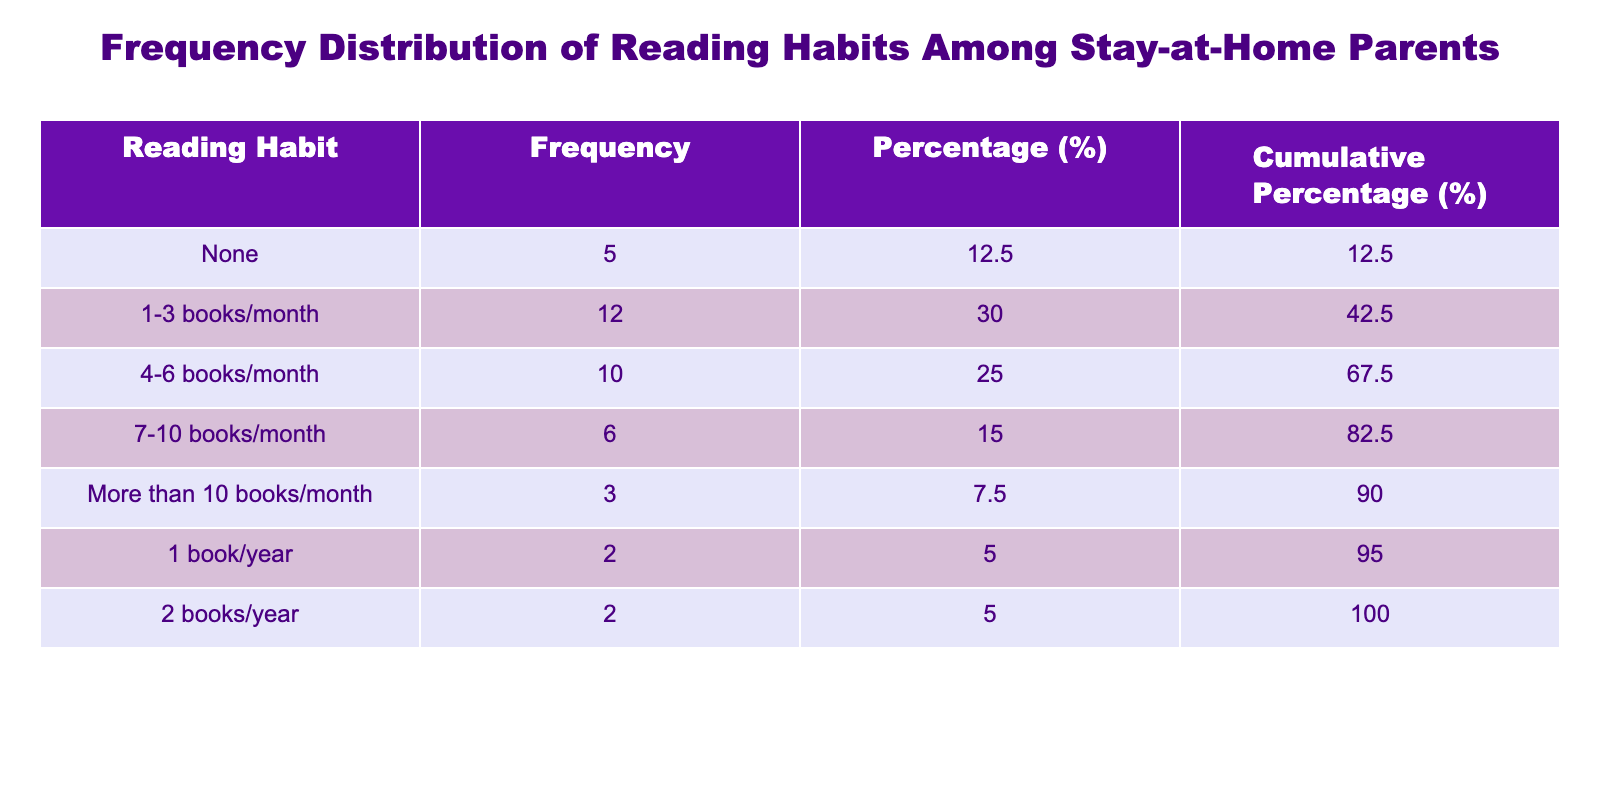What is the frequency of stay-at-home parents who read none? The table shows that the frequency of stay-at-home parents who read none is 5.
Answer: 5 How many parents read between 1 to 3 books per month? The table indicates that 12 parents read between 1 to 3 books per month.
Answer: 12 What is the percentage of stay-at-home parents who read more than 10 books per month? The frequency of parents reading more than 10 books per month is 3. To find the percentage, divide 3 by the total frequency (displays a sum of 50) and multiply by 100: (3/50)*100 = 6.00%.
Answer: 6.00% Is it true that more than half of the surveyed parents read 4 or more books per month? The total frequency of parents who read 4 or more books per month (10 + 6 + 3 = 19) is compared to the total frequency (50). Since 19 is less than 25, it shows that less than half read 4 or more books per month.
Answer: No What is the total frequency of parents reading 1 book per year or 2 books per year? The frequency for 1 book/year is 2 and for 2 books/year is also 2. Adding these gives: 2 + 2 = 4.
Answer: 4 How many more parents prefer to read 1-3 books per month than those who read 7-10 books per month? The frequency for 1-3 books/month is 12 and for 7-10 books/month is 6. The difference is calculated by subtracting: 12 - 6 = 6.
Answer: 6 What is the cumulative percentage of parents who read 1-3 books per month? The cumulative percentage for parents reading 1-3 books per month is calculated based on the percentages of prior categories. The percentage of 1-3 books/month is 24.00%, and prior counts (none) add up to 10%. Thus, 10 + 24 = 34% cumulative for this segment.
Answer: 34.00% How many parents read fewer than 4 books per month? The total frequency of parents reading none, 1-3 books/month, and 1 book/year is needed: 5 (none) + 12 (1-3 books/month) + 2 (1 book/year) = 19.
Answer: 19 What is the average number of books read per month by parents? To find the average, sum the product of the frequency and midpoints of each reading category. So, (0*5 + 2*12 + 5*10 + 8.5*6 + 10+*3) / 50 = (0 + 24 + 50 + 51 + 30) / 50 = 155 / 50 = 3.1, indicating an average of 3.1 books monthly per parent.
Answer: 3.1 